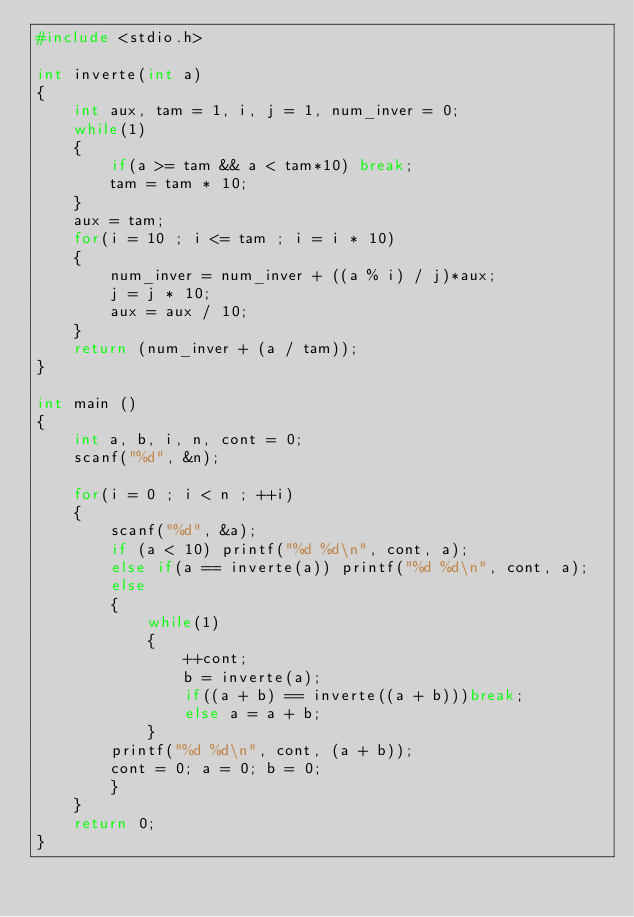Convert code to text. <code><loc_0><loc_0><loc_500><loc_500><_C_>#include <stdio.h>

int inverte(int a)
{
	int aux, tam = 1, i, j = 1, num_inver = 0;
	while(1)
	{
		if(a >= tam && a < tam*10) break;
		tam = tam * 10;
	}
	aux = tam;
	for(i = 10 ; i <= tam ; i = i * 10)
	{
		num_inver = num_inver + ((a % i) / j)*aux;
		j = j * 10;
		aux = aux / 10;
	}
	return (num_inver + (a / tam));
}

int main ()
{
	int a, b, i, n, cont = 0;
	scanf("%d", &n);

	for(i = 0 ; i < n ; ++i)
	{
		scanf("%d", &a);
		if (a < 10) printf("%d %d\n", cont, a);
		else if(a == inverte(a)) printf("%d %d\n", cont, a);
		else
		{
			while(1)
			{
				++cont;
				b = inverte(a);
				if((a + b) == inverte((a + b)))break;
				else a = a + b;
			}
		printf("%d %d\n", cont, (a + b));
		cont = 0; a = 0; b = 0;
		}
	}
	return 0;
}
</code> 